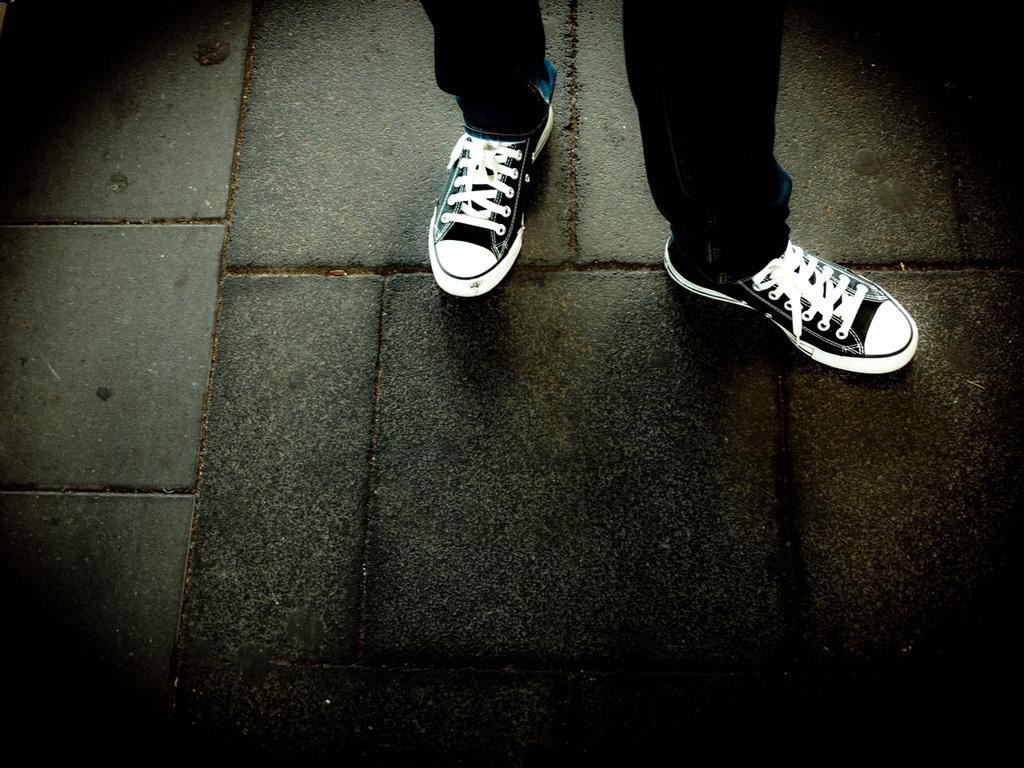What body parts are visible in the image? There are legs visible in the image. What type of clothing is on the legs? The legs have clothing on them. What type of footwear is on the legs? The legs have footwear on them. Where are the legs and footwear located in the image? The legs and footwear are on the floor. What type of punishment is being administered to the corn in the image? There is no corn present in the image, and therefore no punishment is being administered. 